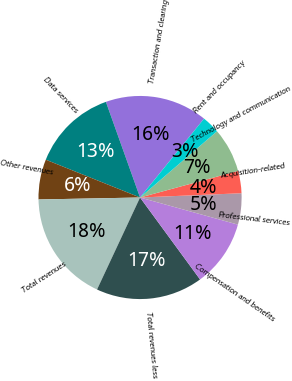<chart> <loc_0><loc_0><loc_500><loc_500><pie_chart><fcel>Transaction and clearing<fcel>Data services<fcel>Other revenues<fcel>Total revenues<fcel>Total revenues less<fcel>Compensation and benefits<fcel>Professional services<fcel>Acquisition-related<fcel>Technology and communication<fcel>Rent and occupancy<nl><fcel>16.31%<fcel>13.47%<fcel>6.38%<fcel>17.73%<fcel>17.02%<fcel>10.64%<fcel>4.97%<fcel>3.55%<fcel>7.09%<fcel>2.84%<nl></chart> 